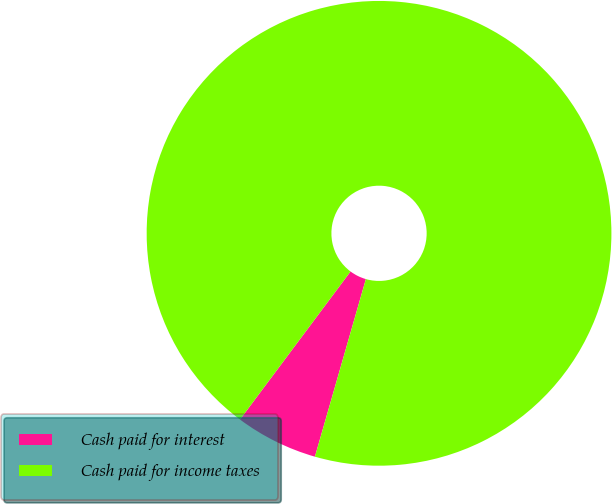Convert chart. <chart><loc_0><loc_0><loc_500><loc_500><pie_chart><fcel>Cash paid for interest<fcel>Cash paid for income taxes<nl><fcel>5.76%<fcel>94.24%<nl></chart> 